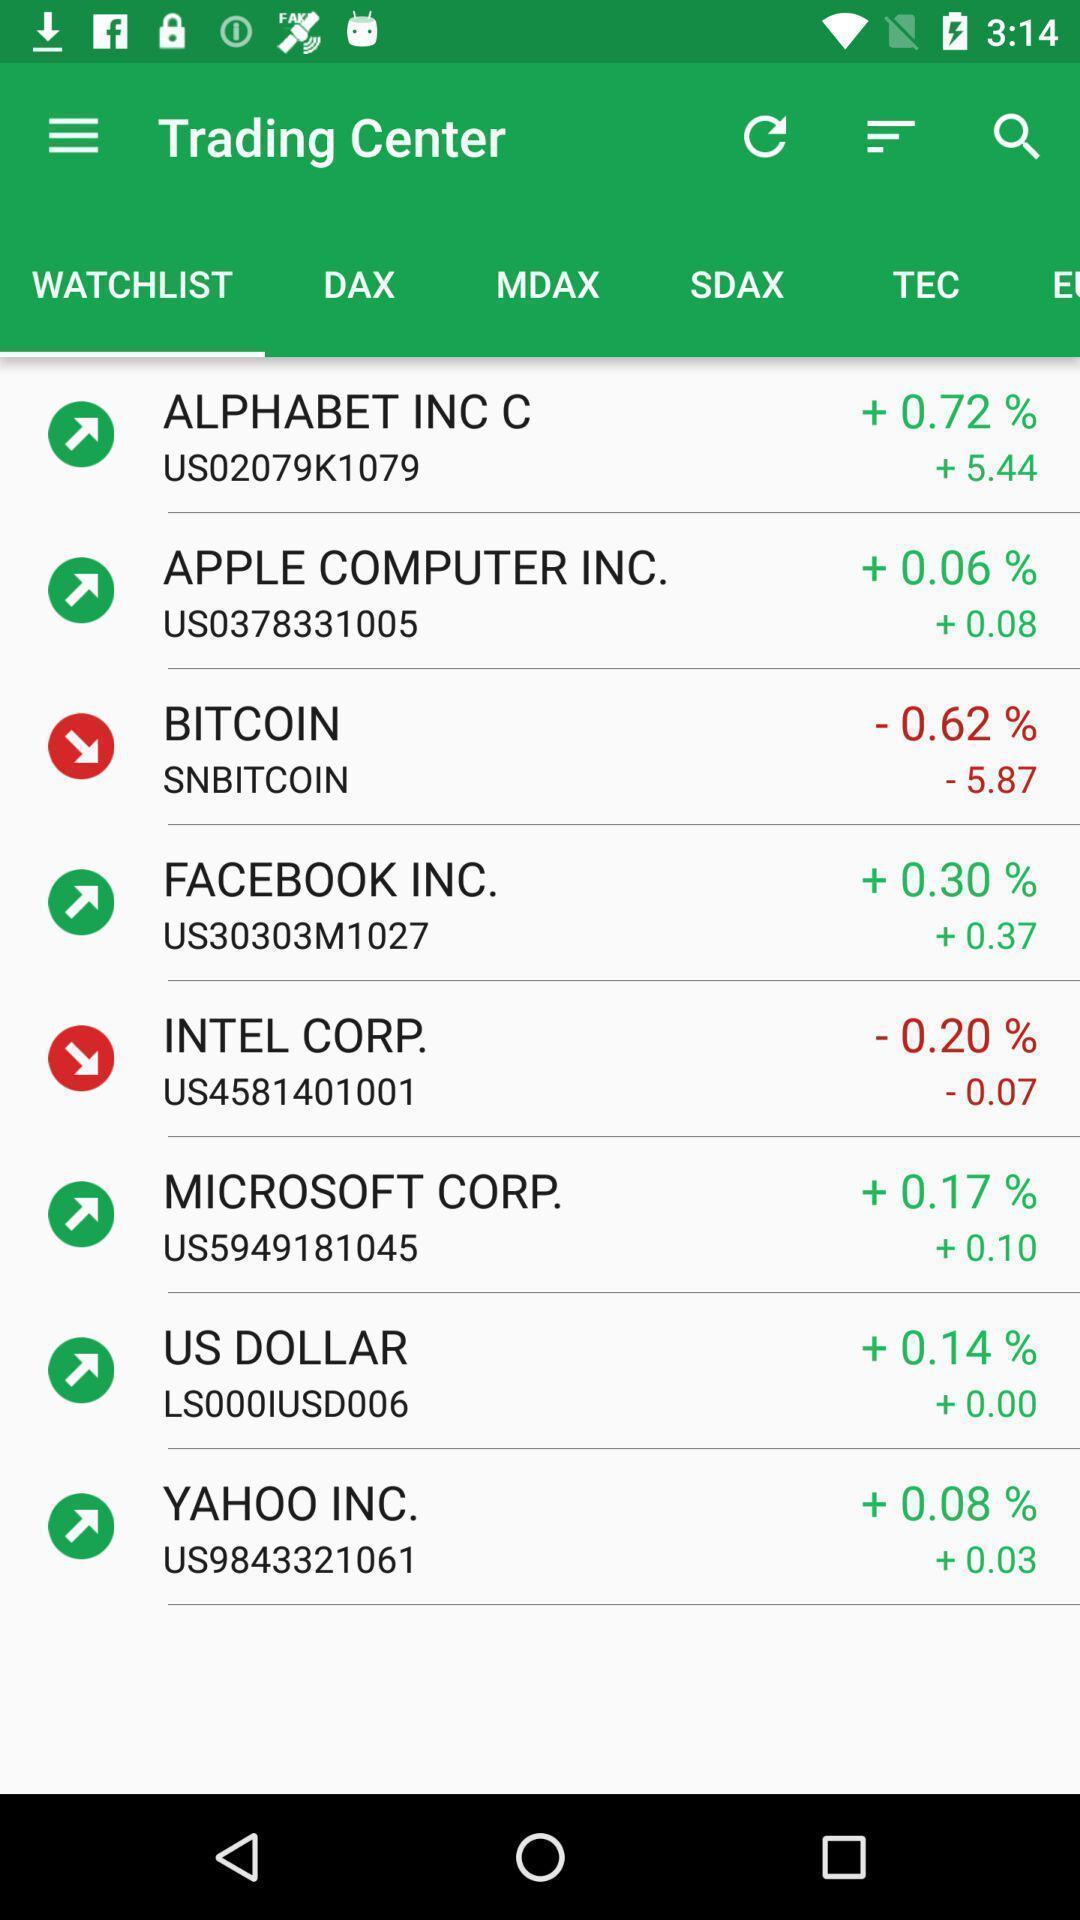What details can you identify in this image? Trading app displayed watchlist and other options. 